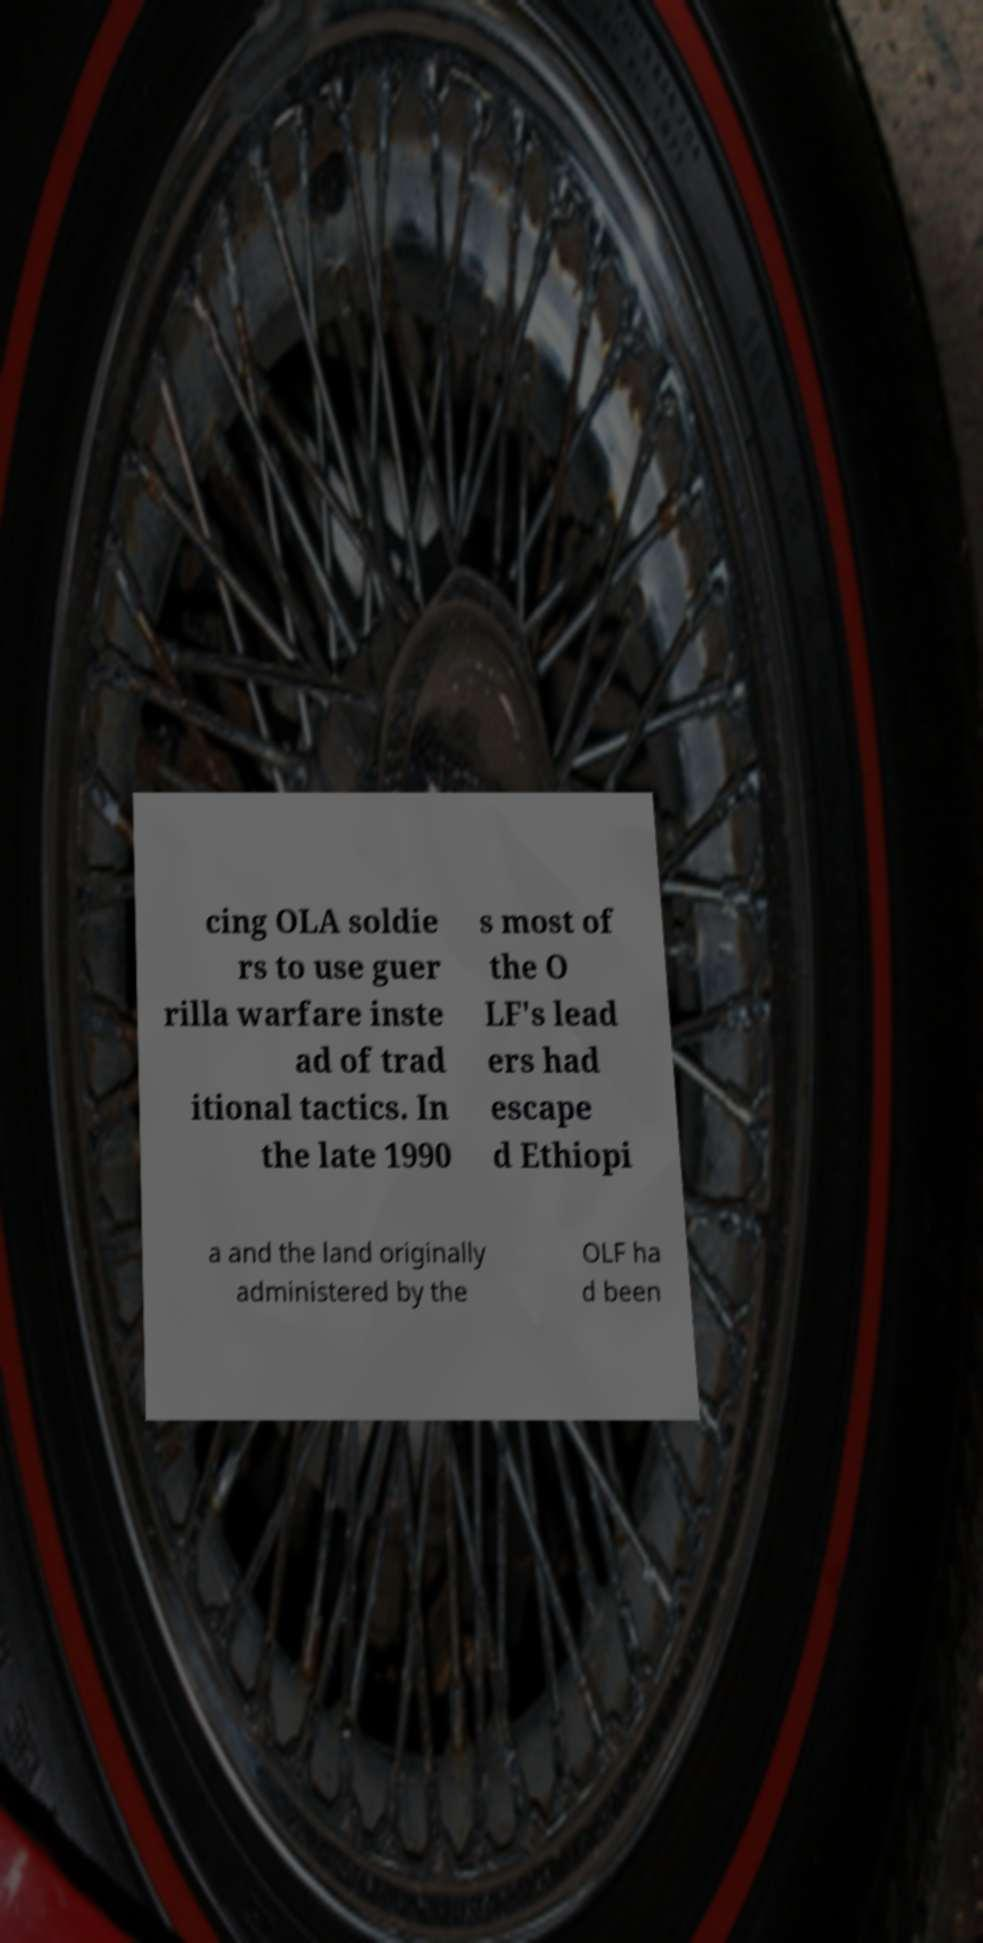I need the written content from this picture converted into text. Can you do that? cing OLA soldie rs to use guer rilla warfare inste ad of trad itional tactics. In the late 1990 s most of the O LF's lead ers had escape d Ethiopi a and the land originally administered by the OLF ha d been 